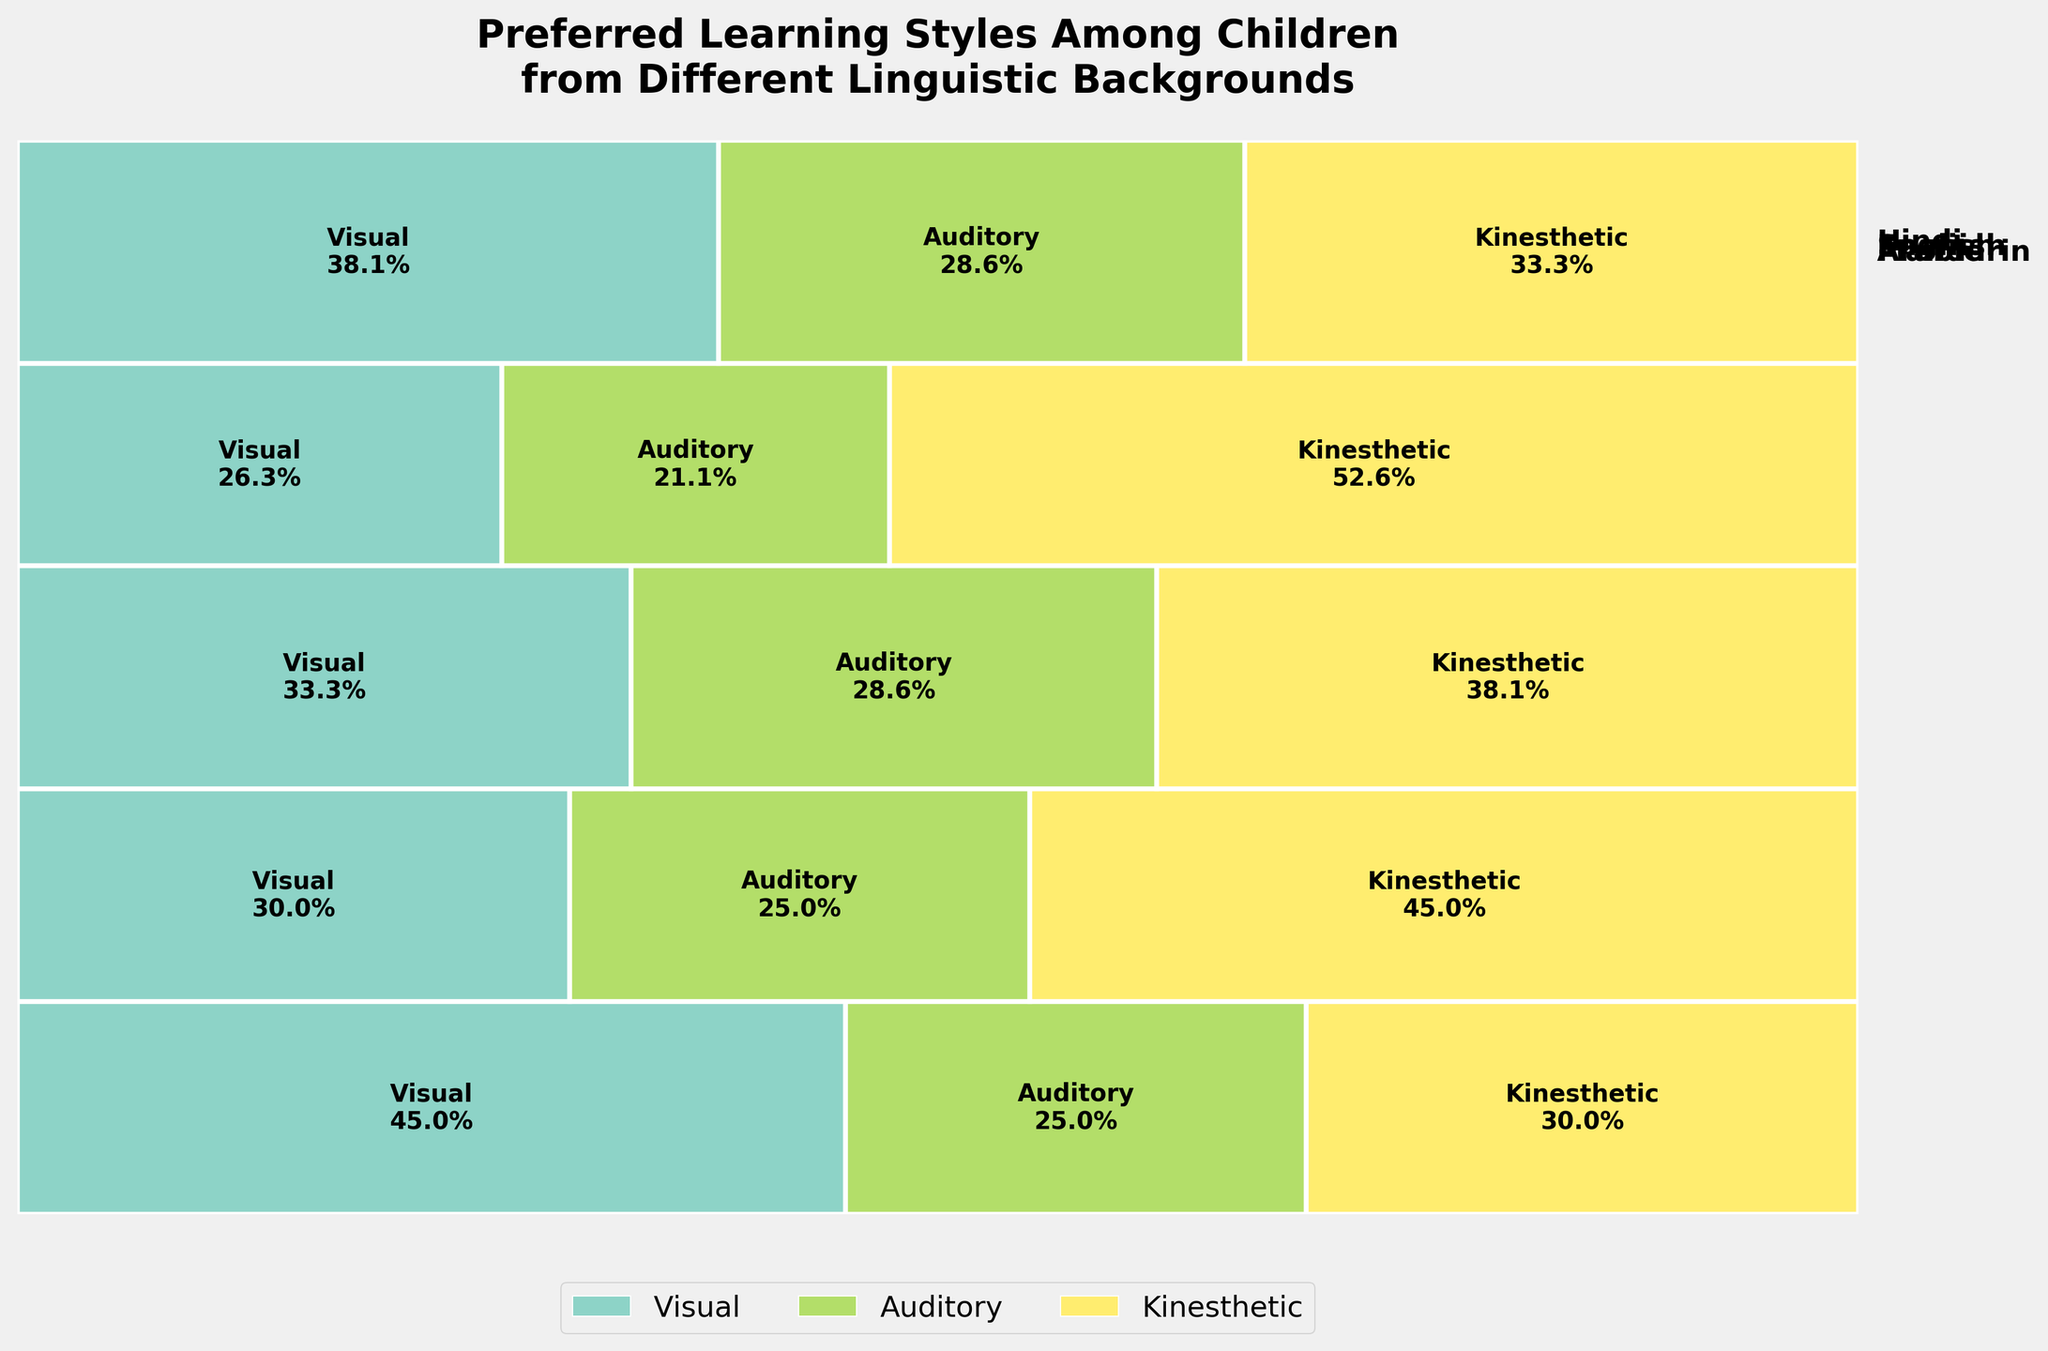What are the different linguistic backgrounds shown in the plot? Look at the labels on the plot. Each label represents a different linguistic background. These are written outside of the plot on the right side.
Answer: English, Spanish, Mandarin, Hindi, Arabic What learning style is most preferred among children with a Mandarin linguistic background? Check for the largest section in the bar corresponding to the Mandarin background. The percentage label inside the section will indicate the most preferred learning style.
Answer: Visual Which linguistic background has the highest proportion of children preferring the auditory learning style? Compare the sizes of the auditory sections across the different linguistic backgrounds. Look for the section with the highest percentage label.
Answer: Arabic How many rectangles are there in total on the plot? Count the number of unique linguistic backgrounds and learning styles. Each combination of background and learning style corresponds to a rectangle. Multiply the number of backgrounds by the number of learning styles.
Answer: 15 Do children from an English linguistic background prefer kinesthetic or visual learning styles more? Compare the sizes of the kinesthetic and visual sections for the English background. The larger section indicates the more preferred style.
Answer: Visual Which learning style has the least preference across children from all linguistic backgrounds combined? Look for the learning style that appears to have consistently smaller sections across all linguistic backgrounds.
Answer: Kinesthetic Which linguistic background has the most children involved in the study? Find the background label closest to the bottom of the plot, indicating the largest total section.
Answer: Mandarin Are there more children preferring auditory learning styles in Spanish or Hindi linguistic backgrounds? Compare the sizes of the auditory sections for Spanish and Hindi. The larger percentage indicates the greater number of children.
Answer: Spanish What percentage of children with an Arabic linguistic background prefer visual learning styles? Check the label inside the visual section for the Arabic background. The label will provide the percentage.
Answer: 30% Which learning style for Mandarin children has nearly half the preference percentage compared to their most preferred learning style? Determine the most preferred learning style for Mandarin children, then find the learning style that has a percentage close to half of that value by examining the section sizes and labels.
Answer: Auditory 